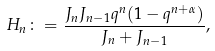Convert formula to latex. <formula><loc_0><loc_0><loc_500><loc_500>H _ { n } \colon = \frac { J _ { n } J _ { n - 1 } q ^ { n } ( 1 - q ^ { n + \alpha } ) } { J _ { n } + J _ { n - 1 } } ,</formula> 